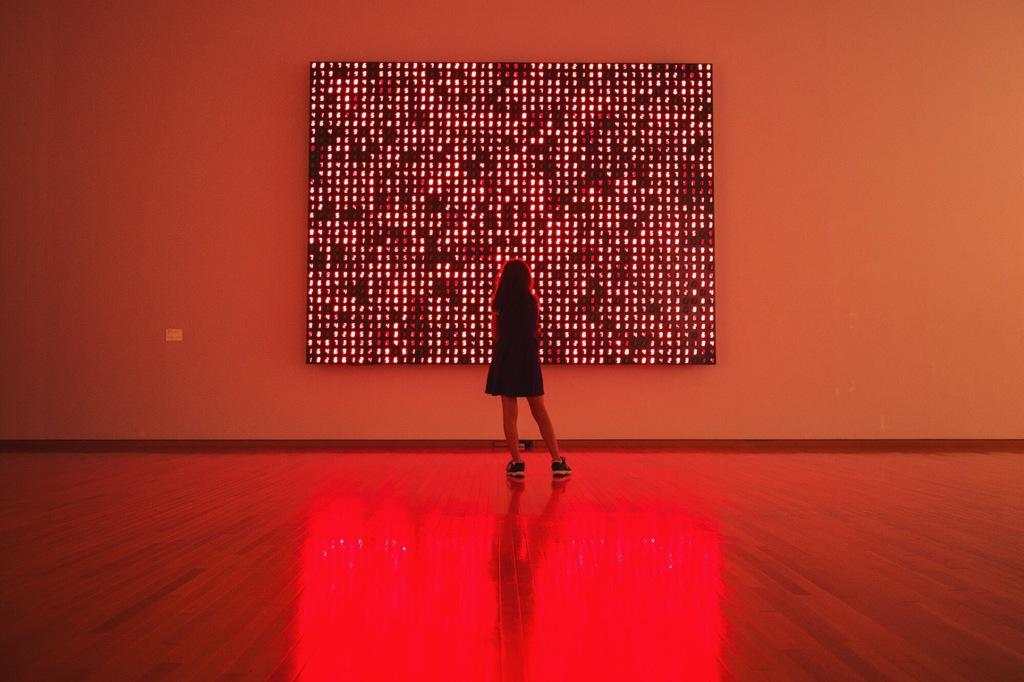Who or what is the main subject in the image? There is a person in the image. What can be seen in the background of the image? There is a wall and an object in the background of the image. What is visible at the bottom of the image? The floor is visible at the bottom of the image. What type of veil is covering the person's face in the image? There is no veil present in the image; the person's face is visible. 